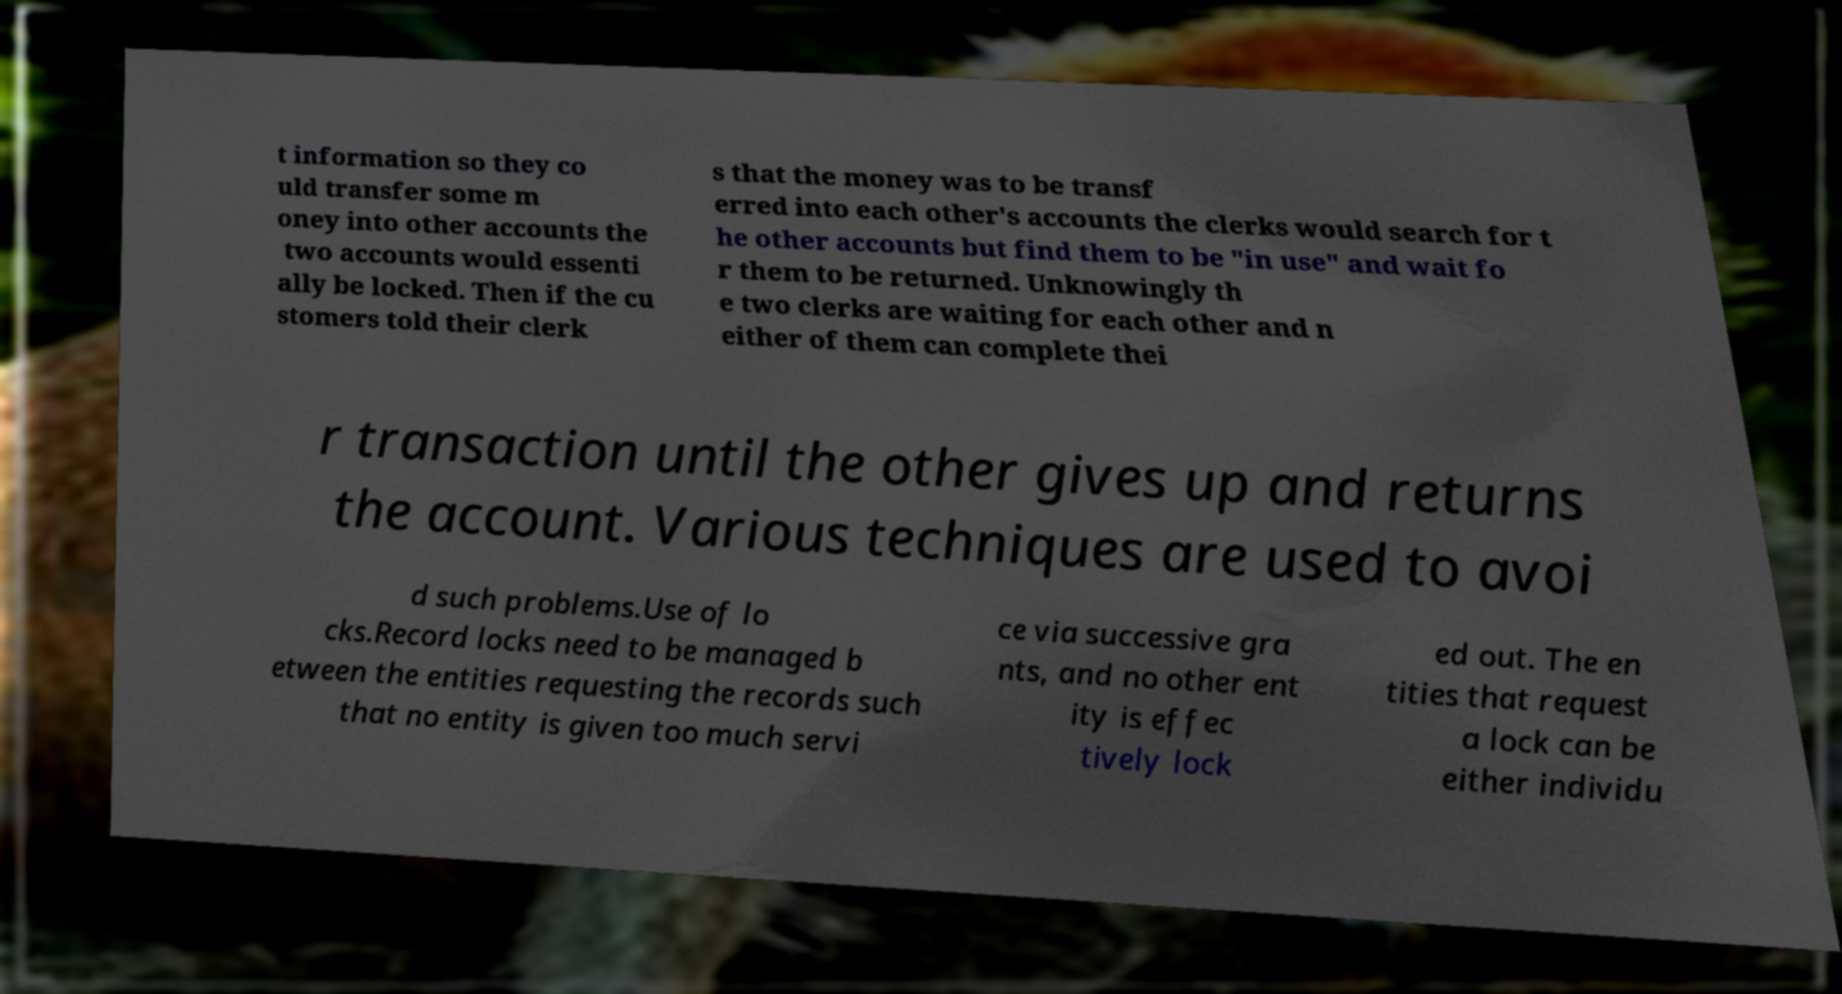Can you accurately transcribe the text from the provided image for me? t information so they co uld transfer some m oney into other accounts the two accounts would essenti ally be locked. Then if the cu stomers told their clerk s that the money was to be transf erred into each other's accounts the clerks would search for t he other accounts but find them to be "in use" and wait fo r them to be returned. Unknowingly th e two clerks are waiting for each other and n either of them can complete thei r transaction until the other gives up and returns the account. Various techniques are used to avoi d such problems.Use of lo cks.Record locks need to be managed b etween the entities requesting the records such that no entity is given too much servi ce via successive gra nts, and no other ent ity is effec tively lock ed out. The en tities that request a lock can be either individu 